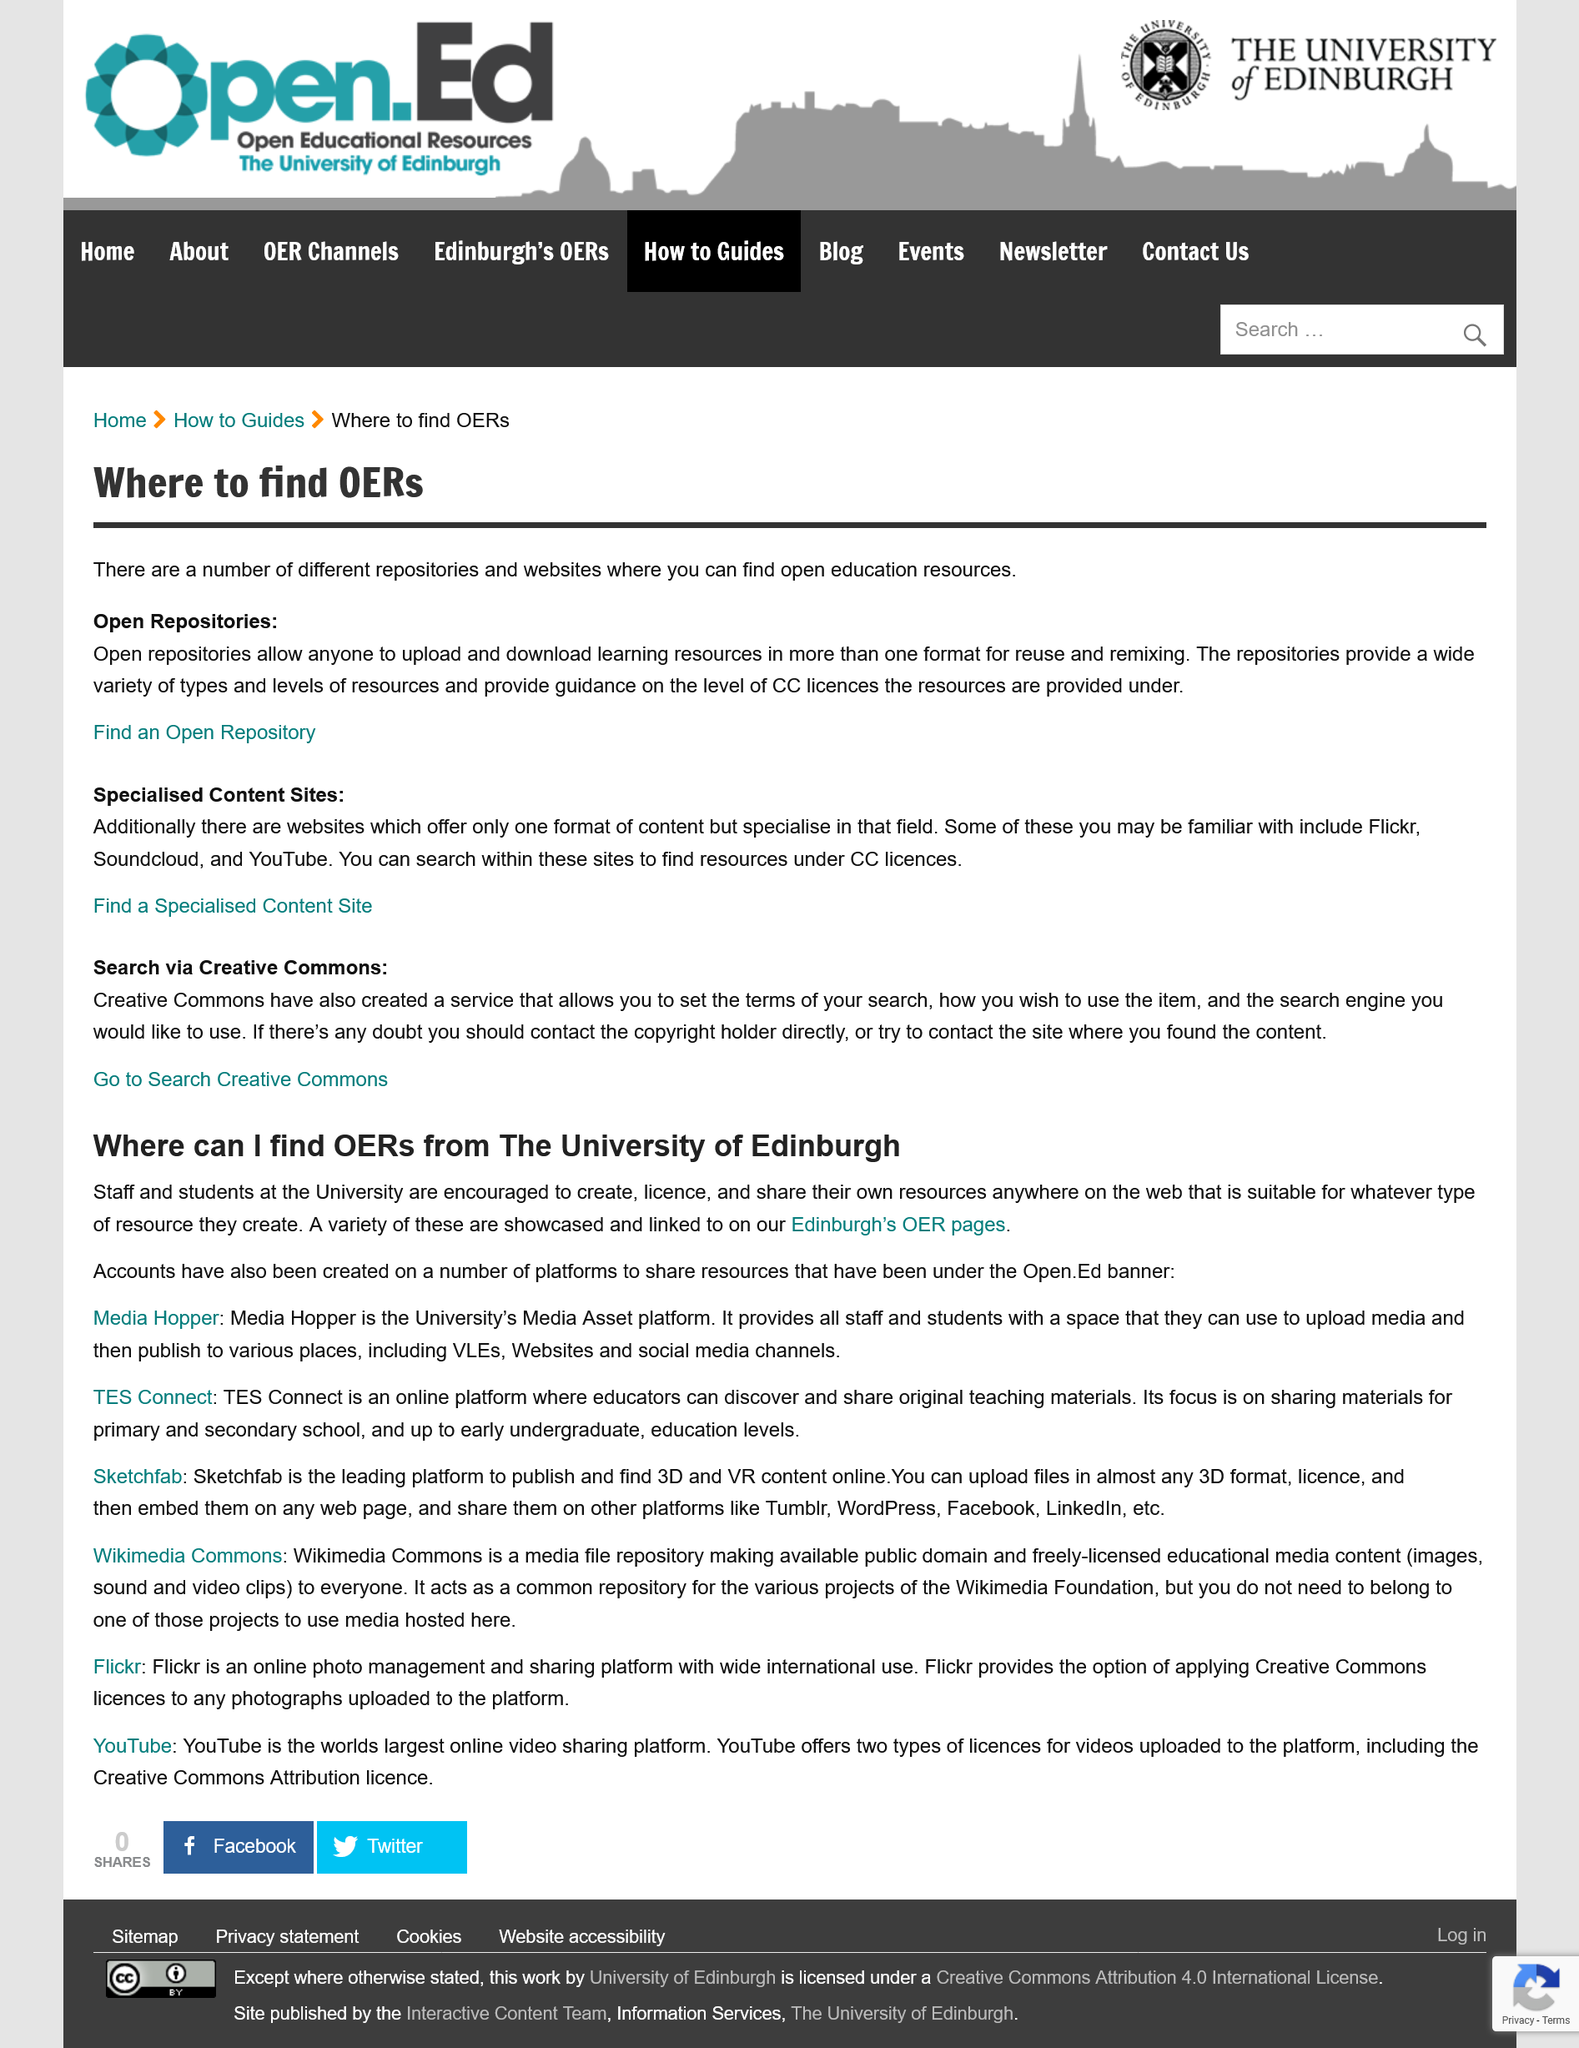Specify some key components in this picture. The University of Edinburgh provides OERs that can be found on its OER pages, which are showcased and linked. Open Repositories allow any individual to upload and download resources. Three specialized content sites, namely Flickr, Soundcloud, and YouTube, are provided as examples in this context. YouTube offers two types of licenses for videos uploaded to its platform. TES Connect allowed users to share a particular type of materials, which were teaching materials. 